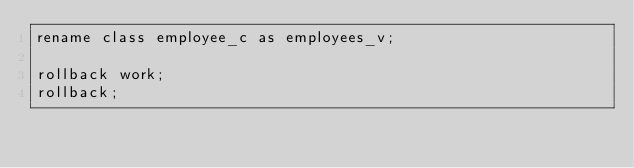Convert code to text. <code><loc_0><loc_0><loc_500><loc_500><_SQL_>rename class employee_c as employees_v;

rollback work;
rollback;
</code> 